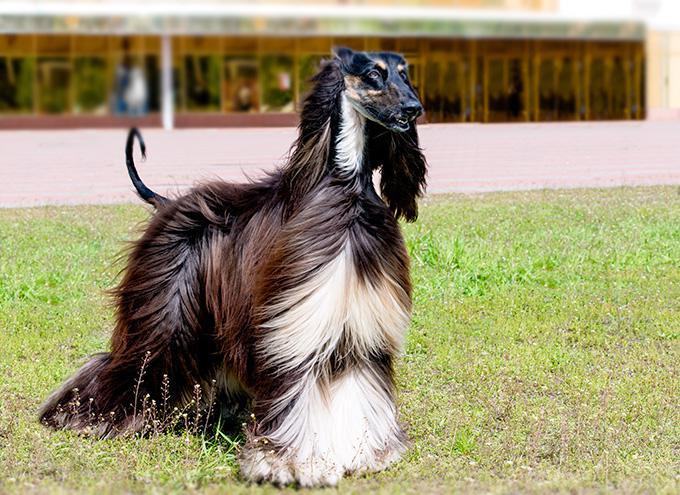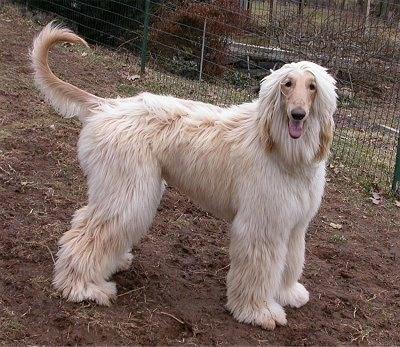The first image is the image on the left, the second image is the image on the right. Analyze the images presented: Is the assertion "Only the dogs head can be seen in the image on the right." valid? Answer yes or no. No. The first image is the image on the left, the second image is the image on the right. Assess this claim about the two images: "The dog in the image on the left is outside.". Correct or not? Answer yes or no. Yes. 